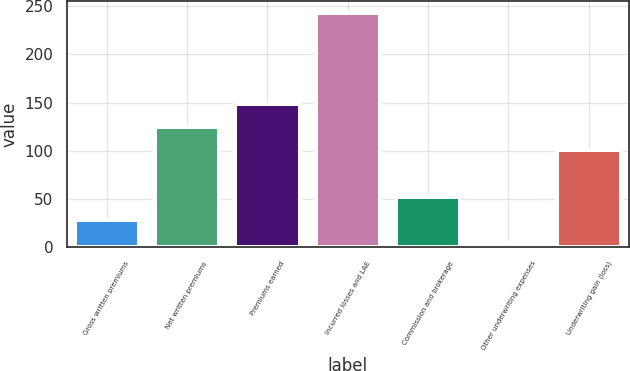<chart> <loc_0><loc_0><loc_500><loc_500><bar_chart><fcel>Gross written premiums<fcel>Net written premiums<fcel>Premiums earned<fcel>Incurred losses and LAE<fcel>Commission and brokerage<fcel>Other underwriting expenses<fcel>Underwriting gain (loss)<nl><fcel>27.94<fcel>124.54<fcel>148.48<fcel>243.4<fcel>51.88<fcel>4<fcel>100.6<nl></chart> 